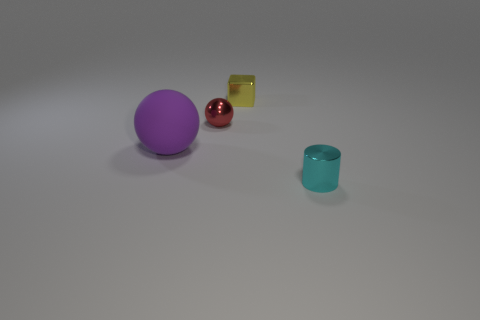Add 1 red spheres. How many objects exist? 5 Subtract all cubes. How many objects are left? 3 Subtract 0 blue balls. How many objects are left? 4 Subtract all big rubber spheres. Subtract all small green spheres. How many objects are left? 3 Add 1 tiny shiny cubes. How many tiny shiny cubes are left? 2 Add 2 tiny brown metal blocks. How many tiny brown metal blocks exist? 2 